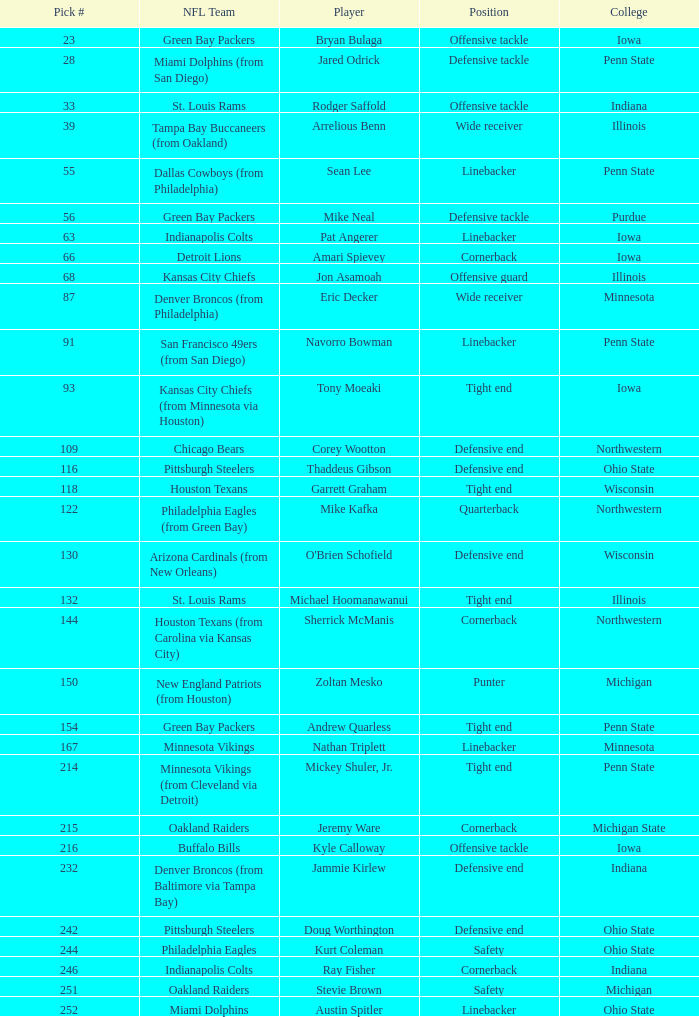What was Sherrick McManis's earliest round? 5.0. 